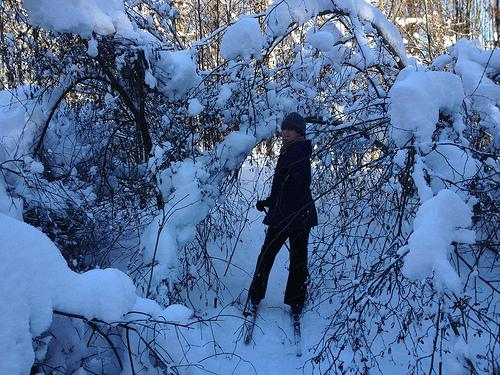Question: where is this skier?
Choices:
A. On the ski lift.
B. On the mountain.
C. In a forest.
D. At the lodge.
Answer with the letter. Answer: C Question: who is in the trees?
Choices:
A. A skier.
B. A bird.
C. A nest.
D. A squirrel.
Answer with the letter. Answer: A Question: when would this form of precipitation fall?
Choices:
A. Fall.
B. Summer.
C. Spring.
D. Winter.
Answer with the letter. Answer: D Question: what color is the substance on the trees?
Choices:
A. White.
B. Grey.
C. Brown.
D. Black.
Answer with the letter. Answer: A Question: what is on the person's feet?
Choices:
A. Skis.
B. Socks.
C. Shoes.
D. Boots.
Answer with the letter. Answer: A Question: how many skis are there?
Choices:
A. 4.
B. 2.
C. 6.
D. 0.
Answer with the letter. Answer: B 